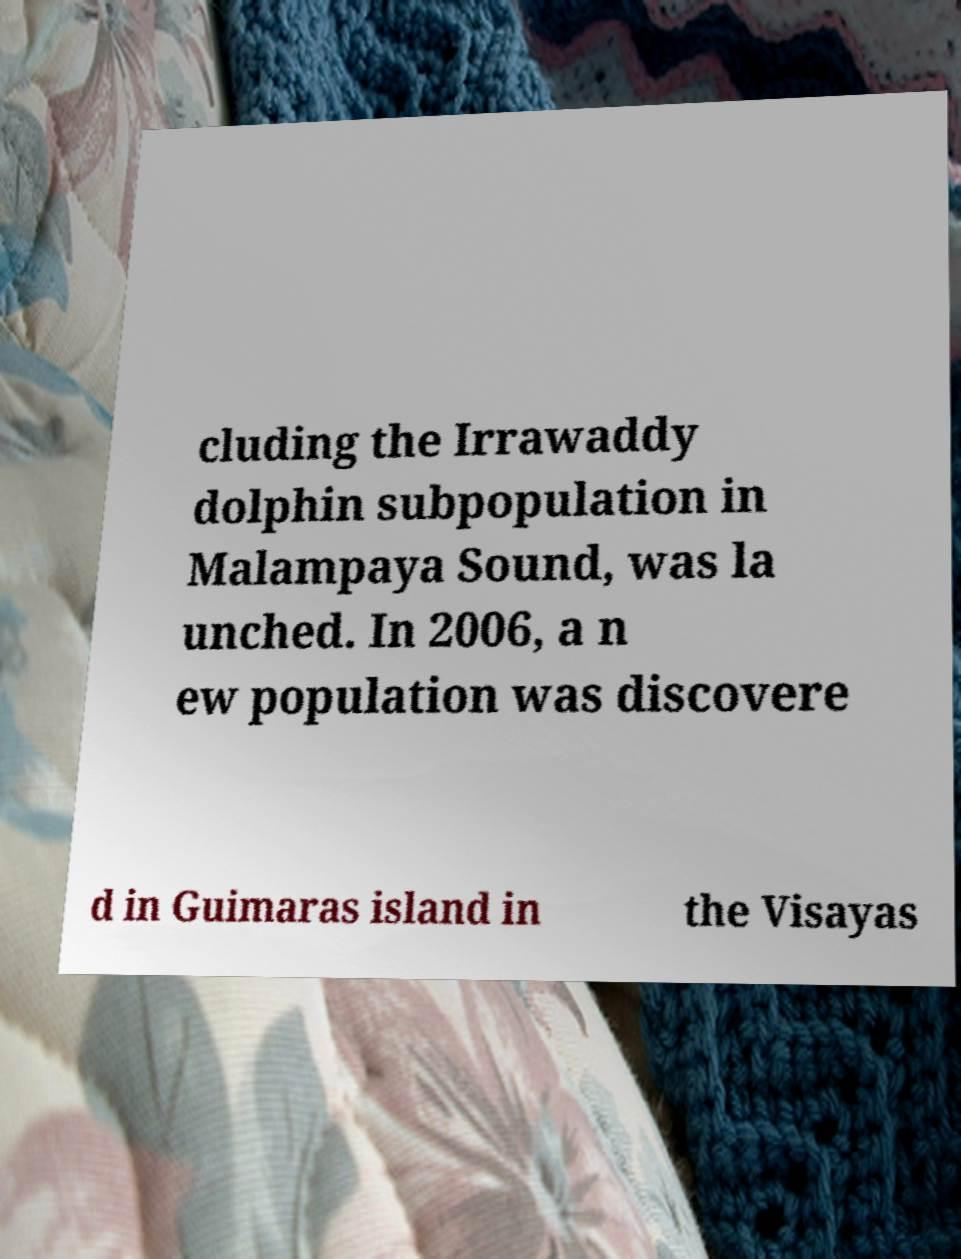Could you assist in decoding the text presented in this image and type it out clearly? cluding the Irrawaddy dolphin subpopulation in Malampaya Sound, was la unched. In 2006, a n ew population was discovere d in Guimaras island in the Visayas 